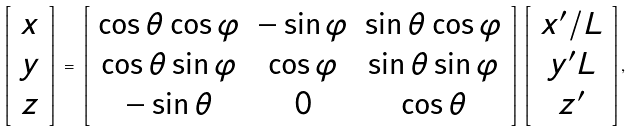Convert formula to latex. <formula><loc_0><loc_0><loc_500><loc_500>\left [ \begin{array} { c } x \\ y \\ z \end{array} \right ] \, = \, \left [ \begin{array} { c c c } \cos \theta \cos \varphi & - \sin \varphi & \sin \theta \cos \varphi \\ \cos \theta \sin \varphi & \cos \varphi & \sin \theta \sin \varphi \\ - \sin \theta & 0 & \cos \theta \end{array} \right ] \, \left [ \begin{array} { c } x ^ { \prime } / L \\ y ^ { \prime } L \\ z ^ { \prime } \end{array} \right ] ,</formula> 